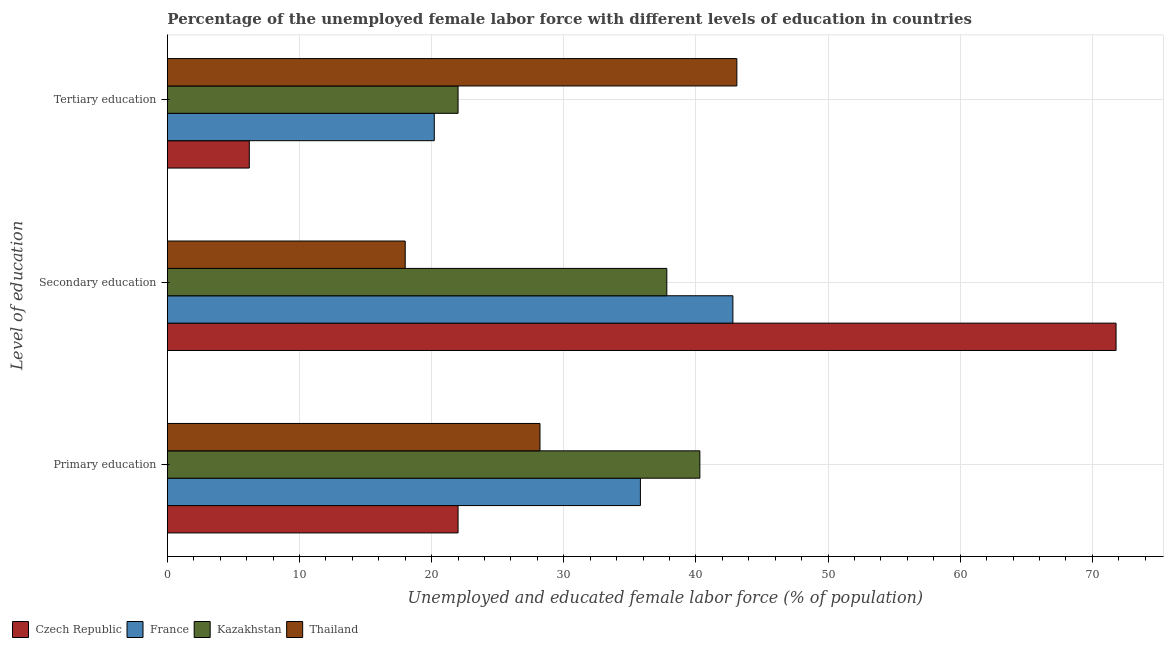How many different coloured bars are there?
Provide a succinct answer. 4. How many groups of bars are there?
Your answer should be very brief. 3. Are the number of bars per tick equal to the number of legend labels?
Ensure brevity in your answer.  Yes. Are the number of bars on each tick of the Y-axis equal?
Your response must be concise. Yes. What is the label of the 1st group of bars from the top?
Offer a terse response. Tertiary education. Across all countries, what is the maximum percentage of female labor force who received primary education?
Make the answer very short. 40.3. In which country was the percentage of female labor force who received primary education maximum?
Provide a succinct answer. Kazakhstan. In which country was the percentage of female labor force who received primary education minimum?
Offer a terse response. Czech Republic. What is the total percentage of female labor force who received primary education in the graph?
Your answer should be very brief. 126.3. What is the difference between the percentage of female labor force who received primary education in Kazakhstan and the percentage of female labor force who received secondary education in Czech Republic?
Provide a short and direct response. -31.5. What is the average percentage of female labor force who received secondary education per country?
Offer a very short reply. 42.6. What is the difference between the percentage of female labor force who received secondary education and percentage of female labor force who received primary education in Czech Republic?
Your answer should be very brief. 49.8. In how many countries, is the percentage of female labor force who received secondary education greater than 12 %?
Offer a very short reply. 4. What is the ratio of the percentage of female labor force who received primary education in Czech Republic to that in France?
Your answer should be compact. 0.61. Is the percentage of female labor force who received secondary education in France less than that in Thailand?
Offer a very short reply. No. Is the difference between the percentage of female labor force who received tertiary education in France and Thailand greater than the difference between the percentage of female labor force who received primary education in France and Thailand?
Give a very brief answer. No. What is the difference between the highest and the second highest percentage of female labor force who received secondary education?
Provide a short and direct response. 29. What is the difference between the highest and the lowest percentage of female labor force who received tertiary education?
Provide a short and direct response. 36.9. In how many countries, is the percentage of female labor force who received primary education greater than the average percentage of female labor force who received primary education taken over all countries?
Offer a terse response. 2. Is the sum of the percentage of female labor force who received secondary education in France and Czech Republic greater than the maximum percentage of female labor force who received primary education across all countries?
Your answer should be compact. Yes. What does the 4th bar from the top in Primary education represents?
Give a very brief answer. Czech Republic. What does the 4th bar from the bottom in Primary education represents?
Ensure brevity in your answer.  Thailand. Are all the bars in the graph horizontal?
Provide a short and direct response. Yes. What is the difference between two consecutive major ticks on the X-axis?
Keep it short and to the point. 10. Does the graph contain any zero values?
Offer a terse response. No. What is the title of the graph?
Give a very brief answer. Percentage of the unemployed female labor force with different levels of education in countries. Does "Libya" appear as one of the legend labels in the graph?
Offer a very short reply. No. What is the label or title of the X-axis?
Keep it short and to the point. Unemployed and educated female labor force (% of population). What is the label or title of the Y-axis?
Keep it short and to the point. Level of education. What is the Unemployed and educated female labor force (% of population) in France in Primary education?
Your answer should be compact. 35.8. What is the Unemployed and educated female labor force (% of population) of Kazakhstan in Primary education?
Your answer should be very brief. 40.3. What is the Unemployed and educated female labor force (% of population) of Thailand in Primary education?
Make the answer very short. 28.2. What is the Unemployed and educated female labor force (% of population) in Czech Republic in Secondary education?
Provide a short and direct response. 71.8. What is the Unemployed and educated female labor force (% of population) in France in Secondary education?
Offer a very short reply. 42.8. What is the Unemployed and educated female labor force (% of population) in Kazakhstan in Secondary education?
Your answer should be compact. 37.8. What is the Unemployed and educated female labor force (% of population) in Thailand in Secondary education?
Keep it short and to the point. 18. What is the Unemployed and educated female labor force (% of population) of Czech Republic in Tertiary education?
Provide a succinct answer. 6.2. What is the Unemployed and educated female labor force (% of population) in France in Tertiary education?
Offer a very short reply. 20.2. What is the Unemployed and educated female labor force (% of population) in Kazakhstan in Tertiary education?
Your response must be concise. 22. What is the Unemployed and educated female labor force (% of population) in Thailand in Tertiary education?
Give a very brief answer. 43.1. Across all Level of education, what is the maximum Unemployed and educated female labor force (% of population) of Czech Republic?
Your answer should be very brief. 71.8. Across all Level of education, what is the maximum Unemployed and educated female labor force (% of population) in France?
Ensure brevity in your answer.  42.8. Across all Level of education, what is the maximum Unemployed and educated female labor force (% of population) of Kazakhstan?
Keep it short and to the point. 40.3. Across all Level of education, what is the maximum Unemployed and educated female labor force (% of population) of Thailand?
Offer a very short reply. 43.1. Across all Level of education, what is the minimum Unemployed and educated female labor force (% of population) in Czech Republic?
Your answer should be very brief. 6.2. Across all Level of education, what is the minimum Unemployed and educated female labor force (% of population) in France?
Your answer should be compact. 20.2. Across all Level of education, what is the minimum Unemployed and educated female labor force (% of population) in Kazakhstan?
Your answer should be compact. 22. Across all Level of education, what is the minimum Unemployed and educated female labor force (% of population) of Thailand?
Your answer should be compact. 18. What is the total Unemployed and educated female labor force (% of population) in France in the graph?
Keep it short and to the point. 98.8. What is the total Unemployed and educated female labor force (% of population) of Kazakhstan in the graph?
Give a very brief answer. 100.1. What is the total Unemployed and educated female labor force (% of population) in Thailand in the graph?
Provide a short and direct response. 89.3. What is the difference between the Unemployed and educated female labor force (% of population) of Czech Republic in Primary education and that in Secondary education?
Offer a terse response. -49.8. What is the difference between the Unemployed and educated female labor force (% of population) of France in Primary education and that in Secondary education?
Ensure brevity in your answer.  -7. What is the difference between the Unemployed and educated female labor force (% of population) in Thailand in Primary education and that in Secondary education?
Give a very brief answer. 10.2. What is the difference between the Unemployed and educated female labor force (% of population) in Czech Republic in Primary education and that in Tertiary education?
Provide a succinct answer. 15.8. What is the difference between the Unemployed and educated female labor force (% of population) in France in Primary education and that in Tertiary education?
Give a very brief answer. 15.6. What is the difference between the Unemployed and educated female labor force (% of population) in Thailand in Primary education and that in Tertiary education?
Keep it short and to the point. -14.9. What is the difference between the Unemployed and educated female labor force (% of population) in Czech Republic in Secondary education and that in Tertiary education?
Your answer should be very brief. 65.6. What is the difference between the Unemployed and educated female labor force (% of population) of France in Secondary education and that in Tertiary education?
Your answer should be very brief. 22.6. What is the difference between the Unemployed and educated female labor force (% of population) of Kazakhstan in Secondary education and that in Tertiary education?
Provide a short and direct response. 15.8. What is the difference between the Unemployed and educated female labor force (% of population) in Thailand in Secondary education and that in Tertiary education?
Keep it short and to the point. -25.1. What is the difference between the Unemployed and educated female labor force (% of population) of Czech Republic in Primary education and the Unemployed and educated female labor force (% of population) of France in Secondary education?
Offer a very short reply. -20.8. What is the difference between the Unemployed and educated female labor force (% of population) of Czech Republic in Primary education and the Unemployed and educated female labor force (% of population) of Kazakhstan in Secondary education?
Keep it short and to the point. -15.8. What is the difference between the Unemployed and educated female labor force (% of population) in Czech Republic in Primary education and the Unemployed and educated female labor force (% of population) in Thailand in Secondary education?
Provide a succinct answer. 4. What is the difference between the Unemployed and educated female labor force (% of population) of France in Primary education and the Unemployed and educated female labor force (% of population) of Kazakhstan in Secondary education?
Keep it short and to the point. -2. What is the difference between the Unemployed and educated female labor force (% of population) in Kazakhstan in Primary education and the Unemployed and educated female labor force (% of population) in Thailand in Secondary education?
Make the answer very short. 22.3. What is the difference between the Unemployed and educated female labor force (% of population) in Czech Republic in Primary education and the Unemployed and educated female labor force (% of population) in Thailand in Tertiary education?
Ensure brevity in your answer.  -21.1. What is the difference between the Unemployed and educated female labor force (% of population) in France in Primary education and the Unemployed and educated female labor force (% of population) in Kazakhstan in Tertiary education?
Provide a short and direct response. 13.8. What is the difference between the Unemployed and educated female labor force (% of population) in Czech Republic in Secondary education and the Unemployed and educated female labor force (% of population) in France in Tertiary education?
Your answer should be compact. 51.6. What is the difference between the Unemployed and educated female labor force (% of population) of Czech Republic in Secondary education and the Unemployed and educated female labor force (% of population) of Kazakhstan in Tertiary education?
Give a very brief answer. 49.8. What is the difference between the Unemployed and educated female labor force (% of population) in Czech Republic in Secondary education and the Unemployed and educated female labor force (% of population) in Thailand in Tertiary education?
Make the answer very short. 28.7. What is the difference between the Unemployed and educated female labor force (% of population) of France in Secondary education and the Unemployed and educated female labor force (% of population) of Kazakhstan in Tertiary education?
Provide a short and direct response. 20.8. What is the average Unemployed and educated female labor force (% of population) in Czech Republic per Level of education?
Give a very brief answer. 33.33. What is the average Unemployed and educated female labor force (% of population) of France per Level of education?
Keep it short and to the point. 32.93. What is the average Unemployed and educated female labor force (% of population) in Kazakhstan per Level of education?
Your answer should be compact. 33.37. What is the average Unemployed and educated female labor force (% of population) in Thailand per Level of education?
Give a very brief answer. 29.77. What is the difference between the Unemployed and educated female labor force (% of population) of Czech Republic and Unemployed and educated female labor force (% of population) of France in Primary education?
Provide a short and direct response. -13.8. What is the difference between the Unemployed and educated female labor force (% of population) of Czech Republic and Unemployed and educated female labor force (% of population) of Kazakhstan in Primary education?
Give a very brief answer. -18.3. What is the difference between the Unemployed and educated female labor force (% of population) in Czech Republic and Unemployed and educated female labor force (% of population) in Thailand in Primary education?
Ensure brevity in your answer.  -6.2. What is the difference between the Unemployed and educated female labor force (% of population) of France and Unemployed and educated female labor force (% of population) of Kazakhstan in Primary education?
Offer a terse response. -4.5. What is the difference between the Unemployed and educated female labor force (% of population) of Czech Republic and Unemployed and educated female labor force (% of population) of Kazakhstan in Secondary education?
Offer a very short reply. 34. What is the difference between the Unemployed and educated female labor force (% of population) in Czech Republic and Unemployed and educated female labor force (% of population) in Thailand in Secondary education?
Offer a very short reply. 53.8. What is the difference between the Unemployed and educated female labor force (% of population) in France and Unemployed and educated female labor force (% of population) in Thailand in Secondary education?
Your response must be concise. 24.8. What is the difference between the Unemployed and educated female labor force (% of population) in Kazakhstan and Unemployed and educated female labor force (% of population) in Thailand in Secondary education?
Provide a succinct answer. 19.8. What is the difference between the Unemployed and educated female labor force (% of population) of Czech Republic and Unemployed and educated female labor force (% of population) of France in Tertiary education?
Offer a very short reply. -14. What is the difference between the Unemployed and educated female labor force (% of population) in Czech Republic and Unemployed and educated female labor force (% of population) in Kazakhstan in Tertiary education?
Ensure brevity in your answer.  -15.8. What is the difference between the Unemployed and educated female labor force (% of population) in Czech Republic and Unemployed and educated female labor force (% of population) in Thailand in Tertiary education?
Offer a very short reply. -36.9. What is the difference between the Unemployed and educated female labor force (% of population) of France and Unemployed and educated female labor force (% of population) of Kazakhstan in Tertiary education?
Your response must be concise. -1.8. What is the difference between the Unemployed and educated female labor force (% of population) of France and Unemployed and educated female labor force (% of population) of Thailand in Tertiary education?
Keep it short and to the point. -22.9. What is the difference between the Unemployed and educated female labor force (% of population) in Kazakhstan and Unemployed and educated female labor force (% of population) in Thailand in Tertiary education?
Keep it short and to the point. -21.1. What is the ratio of the Unemployed and educated female labor force (% of population) in Czech Republic in Primary education to that in Secondary education?
Give a very brief answer. 0.31. What is the ratio of the Unemployed and educated female labor force (% of population) of France in Primary education to that in Secondary education?
Your answer should be very brief. 0.84. What is the ratio of the Unemployed and educated female labor force (% of population) in Kazakhstan in Primary education to that in Secondary education?
Provide a short and direct response. 1.07. What is the ratio of the Unemployed and educated female labor force (% of population) in Thailand in Primary education to that in Secondary education?
Provide a short and direct response. 1.57. What is the ratio of the Unemployed and educated female labor force (% of population) of Czech Republic in Primary education to that in Tertiary education?
Offer a very short reply. 3.55. What is the ratio of the Unemployed and educated female labor force (% of population) in France in Primary education to that in Tertiary education?
Provide a short and direct response. 1.77. What is the ratio of the Unemployed and educated female labor force (% of population) in Kazakhstan in Primary education to that in Tertiary education?
Give a very brief answer. 1.83. What is the ratio of the Unemployed and educated female labor force (% of population) of Thailand in Primary education to that in Tertiary education?
Give a very brief answer. 0.65. What is the ratio of the Unemployed and educated female labor force (% of population) in Czech Republic in Secondary education to that in Tertiary education?
Your response must be concise. 11.58. What is the ratio of the Unemployed and educated female labor force (% of population) of France in Secondary education to that in Tertiary education?
Offer a very short reply. 2.12. What is the ratio of the Unemployed and educated female labor force (% of population) of Kazakhstan in Secondary education to that in Tertiary education?
Provide a succinct answer. 1.72. What is the ratio of the Unemployed and educated female labor force (% of population) in Thailand in Secondary education to that in Tertiary education?
Make the answer very short. 0.42. What is the difference between the highest and the second highest Unemployed and educated female labor force (% of population) in Czech Republic?
Keep it short and to the point. 49.8. What is the difference between the highest and the second highest Unemployed and educated female labor force (% of population) in France?
Offer a terse response. 7. What is the difference between the highest and the second highest Unemployed and educated female labor force (% of population) of Kazakhstan?
Provide a succinct answer. 2.5. What is the difference between the highest and the lowest Unemployed and educated female labor force (% of population) in Czech Republic?
Your response must be concise. 65.6. What is the difference between the highest and the lowest Unemployed and educated female labor force (% of population) of France?
Offer a very short reply. 22.6. What is the difference between the highest and the lowest Unemployed and educated female labor force (% of population) of Thailand?
Provide a succinct answer. 25.1. 